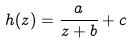Convert formula to latex. <formula><loc_0><loc_0><loc_500><loc_500>h ( z ) = \frac { a } { z + b } + c</formula> 